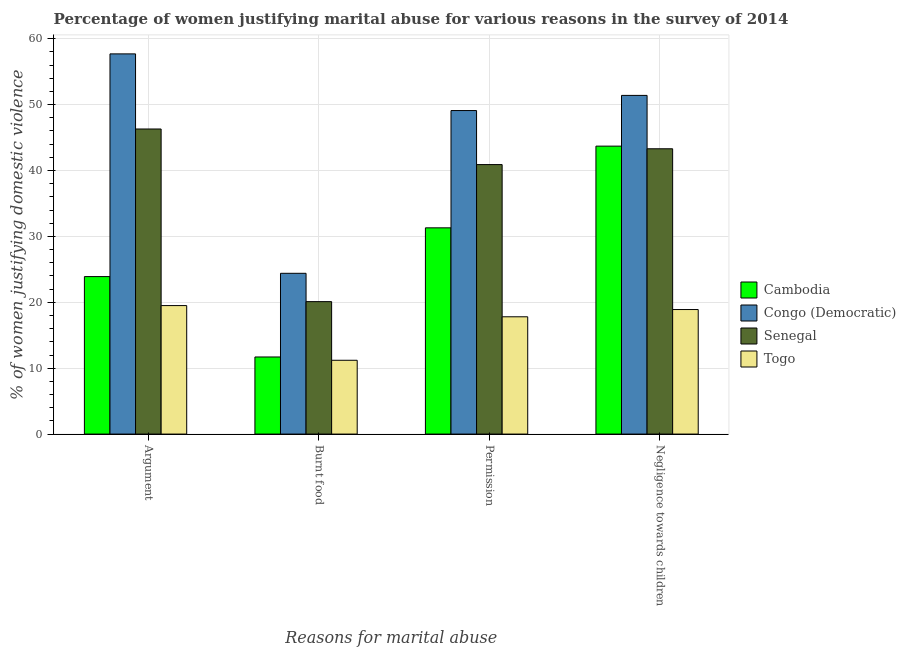How many different coloured bars are there?
Provide a succinct answer. 4. How many groups of bars are there?
Give a very brief answer. 4. Are the number of bars per tick equal to the number of legend labels?
Provide a short and direct response. Yes. What is the label of the 2nd group of bars from the left?
Your response must be concise. Burnt food. What is the percentage of women justifying abuse for showing negligence towards children in Senegal?
Offer a terse response. 43.3. Across all countries, what is the maximum percentage of women justifying abuse in the case of an argument?
Offer a terse response. 57.7. Across all countries, what is the minimum percentage of women justifying abuse for burning food?
Give a very brief answer. 11.2. In which country was the percentage of women justifying abuse for going without permission maximum?
Provide a short and direct response. Congo (Democratic). In which country was the percentage of women justifying abuse for showing negligence towards children minimum?
Give a very brief answer. Togo. What is the total percentage of women justifying abuse for showing negligence towards children in the graph?
Offer a terse response. 157.3. What is the difference between the percentage of women justifying abuse for showing negligence towards children in Congo (Democratic) and that in Cambodia?
Offer a terse response. 7.7. What is the difference between the percentage of women justifying abuse in the case of an argument in Senegal and the percentage of women justifying abuse for showing negligence towards children in Congo (Democratic)?
Ensure brevity in your answer.  -5.1. What is the average percentage of women justifying abuse for going without permission per country?
Offer a terse response. 34.78. What is the difference between the percentage of women justifying abuse for showing negligence towards children and percentage of women justifying abuse for going without permission in Cambodia?
Give a very brief answer. 12.4. In how many countries, is the percentage of women justifying abuse for going without permission greater than 58 %?
Your answer should be compact. 0. What is the ratio of the percentage of women justifying abuse in the case of an argument in Congo (Democratic) to that in Senegal?
Your response must be concise. 1.25. Is the difference between the percentage of women justifying abuse for going without permission in Cambodia and Togo greater than the difference between the percentage of women justifying abuse for burning food in Cambodia and Togo?
Provide a succinct answer. Yes. What is the difference between the highest and the second highest percentage of women justifying abuse for showing negligence towards children?
Provide a short and direct response. 7.7. What is the difference between the highest and the lowest percentage of women justifying abuse for going without permission?
Your response must be concise. 31.3. Is the sum of the percentage of women justifying abuse for showing negligence towards children in Cambodia and Senegal greater than the maximum percentage of women justifying abuse in the case of an argument across all countries?
Make the answer very short. Yes. What does the 4th bar from the left in Permission represents?
Your answer should be very brief. Togo. What does the 2nd bar from the right in Permission represents?
Provide a succinct answer. Senegal. Is it the case that in every country, the sum of the percentage of women justifying abuse in the case of an argument and percentage of women justifying abuse for burning food is greater than the percentage of women justifying abuse for going without permission?
Your answer should be compact. Yes. How many bars are there?
Provide a succinct answer. 16. Are all the bars in the graph horizontal?
Your answer should be compact. No. How many countries are there in the graph?
Your response must be concise. 4. Are the values on the major ticks of Y-axis written in scientific E-notation?
Provide a short and direct response. No. How many legend labels are there?
Give a very brief answer. 4. How are the legend labels stacked?
Give a very brief answer. Vertical. What is the title of the graph?
Provide a short and direct response. Percentage of women justifying marital abuse for various reasons in the survey of 2014. Does "Timor-Leste" appear as one of the legend labels in the graph?
Provide a short and direct response. No. What is the label or title of the X-axis?
Your answer should be compact. Reasons for marital abuse. What is the label or title of the Y-axis?
Give a very brief answer. % of women justifying domestic violence. What is the % of women justifying domestic violence in Cambodia in Argument?
Make the answer very short. 23.9. What is the % of women justifying domestic violence of Congo (Democratic) in Argument?
Make the answer very short. 57.7. What is the % of women justifying domestic violence in Senegal in Argument?
Ensure brevity in your answer.  46.3. What is the % of women justifying domestic violence in Togo in Argument?
Give a very brief answer. 19.5. What is the % of women justifying domestic violence in Cambodia in Burnt food?
Provide a succinct answer. 11.7. What is the % of women justifying domestic violence of Congo (Democratic) in Burnt food?
Offer a very short reply. 24.4. What is the % of women justifying domestic violence in Senegal in Burnt food?
Provide a succinct answer. 20.1. What is the % of women justifying domestic violence in Togo in Burnt food?
Offer a terse response. 11.2. What is the % of women justifying domestic violence in Cambodia in Permission?
Ensure brevity in your answer.  31.3. What is the % of women justifying domestic violence of Congo (Democratic) in Permission?
Make the answer very short. 49.1. What is the % of women justifying domestic violence in Senegal in Permission?
Give a very brief answer. 40.9. What is the % of women justifying domestic violence of Togo in Permission?
Provide a succinct answer. 17.8. What is the % of women justifying domestic violence of Cambodia in Negligence towards children?
Your response must be concise. 43.7. What is the % of women justifying domestic violence in Congo (Democratic) in Negligence towards children?
Ensure brevity in your answer.  51.4. What is the % of women justifying domestic violence of Senegal in Negligence towards children?
Keep it short and to the point. 43.3. What is the % of women justifying domestic violence in Togo in Negligence towards children?
Your answer should be very brief. 18.9. Across all Reasons for marital abuse, what is the maximum % of women justifying domestic violence of Cambodia?
Ensure brevity in your answer.  43.7. Across all Reasons for marital abuse, what is the maximum % of women justifying domestic violence in Congo (Democratic)?
Offer a terse response. 57.7. Across all Reasons for marital abuse, what is the maximum % of women justifying domestic violence in Senegal?
Offer a terse response. 46.3. Across all Reasons for marital abuse, what is the maximum % of women justifying domestic violence in Togo?
Keep it short and to the point. 19.5. Across all Reasons for marital abuse, what is the minimum % of women justifying domestic violence of Cambodia?
Give a very brief answer. 11.7. Across all Reasons for marital abuse, what is the minimum % of women justifying domestic violence in Congo (Democratic)?
Your answer should be very brief. 24.4. Across all Reasons for marital abuse, what is the minimum % of women justifying domestic violence of Senegal?
Provide a succinct answer. 20.1. Across all Reasons for marital abuse, what is the minimum % of women justifying domestic violence of Togo?
Offer a terse response. 11.2. What is the total % of women justifying domestic violence in Cambodia in the graph?
Make the answer very short. 110.6. What is the total % of women justifying domestic violence in Congo (Democratic) in the graph?
Keep it short and to the point. 182.6. What is the total % of women justifying domestic violence of Senegal in the graph?
Ensure brevity in your answer.  150.6. What is the total % of women justifying domestic violence in Togo in the graph?
Provide a succinct answer. 67.4. What is the difference between the % of women justifying domestic violence of Congo (Democratic) in Argument and that in Burnt food?
Your answer should be compact. 33.3. What is the difference between the % of women justifying domestic violence of Senegal in Argument and that in Burnt food?
Make the answer very short. 26.2. What is the difference between the % of women justifying domestic violence in Togo in Argument and that in Burnt food?
Your response must be concise. 8.3. What is the difference between the % of women justifying domestic violence in Togo in Argument and that in Permission?
Make the answer very short. 1.7. What is the difference between the % of women justifying domestic violence in Cambodia in Argument and that in Negligence towards children?
Your response must be concise. -19.8. What is the difference between the % of women justifying domestic violence of Congo (Democratic) in Argument and that in Negligence towards children?
Give a very brief answer. 6.3. What is the difference between the % of women justifying domestic violence of Cambodia in Burnt food and that in Permission?
Ensure brevity in your answer.  -19.6. What is the difference between the % of women justifying domestic violence of Congo (Democratic) in Burnt food and that in Permission?
Ensure brevity in your answer.  -24.7. What is the difference between the % of women justifying domestic violence in Senegal in Burnt food and that in Permission?
Your response must be concise. -20.8. What is the difference between the % of women justifying domestic violence in Togo in Burnt food and that in Permission?
Make the answer very short. -6.6. What is the difference between the % of women justifying domestic violence of Cambodia in Burnt food and that in Negligence towards children?
Provide a succinct answer. -32. What is the difference between the % of women justifying domestic violence in Congo (Democratic) in Burnt food and that in Negligence towards children?
Offer a very short reply. -27. What is the difference between the % of women justifying domestic violence of Senegal in Burnt food and that in Negligence towards children?
Offer a terse response. -23.2. What is the difference between the % of women justifying domestic violence in Togo in Burnt food and that in Negligence towards children?
Ensure brevity in your answer.  -7.7. What is the difference between the % of women justifying domestic violence in Cambodia in Permission and that in Negligence towards children?
Provide a short and direct response. -12.4. What is the difference between the % of women justifying domestic violence in Congo (Democratic) in Permission and that in Negligence towards children?
Make the answer very short. -2.3. What is the difference between the % of women justifying domestic violence of Senegal in Permission and that in Negligence towards children?
Provide a short and direct response. -2.4. What is the difference between the % of women justifying domestic violence of Togo in Permission and that in Negligence towards children?
Offer a terse response. -1.1. What is the difference between the % of women justifying domestic violence in Congo (Democratic) in Argument and the % of women justifying domestic violence in Senegal in Burnt food?
Your answer should be compact. 37.6. What is the difference between the % of women justifying domestic violence of Congo (Democratic) in Argument and the % of women justifying domestic violence of Togo in Burnt food?
Your answer should be very brief. 46.5. What is the difference between the % of women justifying domestic violence of Senegal in Argument and the % of women justifying domestic violence of Togo in Burnt food?
Keep it short and to the point. 35.1. What is the difference between the % of women justifying domestic violence in Cambodia in Argument and the % of women justifying domestic violence in Congo (Democratic) in Permission?
Give a very brief answer. -25.2. What is the difference between the % of women justifying domestic violence of Cambodia in Argument and the % of women justifying domestic violence of Togo in Permission?
Keep it short and to the point. 6.1. What is the difference between the % of women justifying domestic violence in Congo (Democratic) in Argument and the % of women justifying domestic violence in Togo in Permission?
Offer a terse response. 39.9. What is the difference between the % of women justifying domestic violence in Cambodia in Argument and the % of women justifying domestic violence in Congo (Democratic) in Negligence towards children?
Provide a succinct answer. -27.5. What is the difference between the % of women justifying domestic violence of Cambodia in Argument and the % of women justifying domestic violence of Senegal in Negligence towards children?
Ensure brevity in your answer.  -19.4. What is the difference between the % of women justifying domestic violence in Cambodia in Argument and the % of women justifying domestic violence in Togo in Negligence towards children?
Offer a terse response. 5. What is the difference between the % of women justifying domestic violence of Congo (Democratic) in Argument and the % of women justifying domestic violence of Togo in Negligence towards children?
Your answer should be very brief. 38.8. What is the difference between the % of women justifying domestic violence of Senegal in Argument and the % of women justifying domestic violence of Togo in Negligence towards children?
Provide a short and direct response. 27.4. What is the difference between the % of women justifying domestic violence of Cambodia in Burnt food and the % of women justifying domestic violence of Congo (Democratic) in Permission?
Provide a succinct answer. -37.4. What is the difference between the % of women justifying domestic violence in Cambodia in Burnt food and the % of women justifying domestic violence in Senegal in Permission?
Your answer should be compact. -29.2. What is the difference between the % of women justifying domestic violence in Congo (Democratic) in Burnt food and the % of women justifying domestic violence in Senegal in Permission?
Your answer should be compact. -16.5. What is the difference between the % of women justifying domestic violence of Congo (Democratic) in Burnt food and the % of women justifying domestic violence of Togo in Permission?
Make the answer very short. 6.6. What is the difference between the % of women justifying domestic violence in Cambodia in Burnt food and the % of women justifying domestic violence in Congo (Democratic) in Negligence towards children?
Your answer should be compact. -39.7. What is the difference between the % of women justifying domestic violence of Cambodia in Burnt food and the % of women justifying domestic violence of Senegal in Negligence towards children?
Your answer should be very brief. -31.6. What is the difference between the % of women justifying domestic violence in Cambodia in Burnt food and the % of women justifying domestic violence in Togo in Negligence towards children?
Your response must be concise. -7.2. What is the difference between the % of women justifying domestic violence in Congo (Democratic) in Burnt food and the % of women justifying domestic violence in Senegal in Negligence towards children?
Your response must be concise. -18.9. What is the difference between the % of women justifying domestic violence of Congo (Democratic) in Burnt food and the % of women justifying domestic violence of Togo in Negligence towards children?
Your response must be concise. 5.5. What is the difference between the % of women justifying domestic violence of Cambodia in Permission and the % of women justifying domestic violence of Congo (Democratic) in Negligence towards children?
Your answer should be very brief. -20.1. What is the difference between the % of women justifying domestic violence in Cambodia in Permission and the % of women justifying domestic violence in Senegal in Negligence towards children?
Offer a terse response. -12. What is the difference between the % of women justifying domestic violence of Cambodia in Permission and the % of women justifying domestic violence of Togo in Negligence towards children?
Give a very brief answer. 12.4. What is the difference between the % of women justifying domestic violence of Congo (Democratic) in Permission and the % of women justifying domestic violence of Togo in Negligence towards children?
Your answer should be compact. 30.2. What is the difference between the % of women justifying domestic violence of Senegal in Permission and the % of women justifying domestic violence of Togo in Negligence towards children?
Your response must be concise. 22. What is the average % of women justifying domestic violence in Cambodia per Reasons for marital abuse?
Offer a terse response. 27.65. What is the average % of women justifying domestic violence in Congo (Democratic) per Reasons for marital abuse?
Ensure brevity in your answer.  45.65. What is the average % of women justifying domestic violence of Senegal per Reasons for marital abuse?
Provide a short and direct response. 37.65. What is the average % of women justifying domestic violence in Togo per Reasons for marital abuse?
Give a very brief answer. 16.85. What is the difference between the % of women justifying domestic violence of Cambodia and % of women justifying domestic violence of Congo (Democratic) in Argument?
Provide a short and direct response. -33.8. What is the difference between the % of women justifying domestic violence of Cambodia and % of women justifying domestic violence of Senegal in Argument?
Give a very brief answer. -22.4. What is the difference between the % of women justifying domestic violence of Cambodia and % of women justifying domestic violence of Togo in Argument?
Ensure brevity in your answer.  4.4. What is the difference between the % of women justifying domestic violence of Congo (Democratic) and % of women justifying domestic violence of Togo in Argument?
Provide a short and direct response. 38.2. What is the difference between the % of women justifying domestic violence in Senegal and % of women justifying domestic violence in Togo in Argument?
Ensure brevity in your answer.  26.8. What is the difference between the % of women justifying domestic violence in Congo (Democratic) and % of women justifying domestic violence in Senegal in Burnt food?
Keep it short and to the point. 4.3. What is the difference between the % of women justifying domestic violence in Congo (Democratic) and % of women justifying domestic violence in Togo in Burnt food?
Your answer should be compact. 13.2. What is the difference between the % of women justifying domestic violence in Cambodia and % of women justifying domestic violence in Congo (Democratic) in Permission?
Make the answer very short. -17.8. What is the difference between the % of women justifying domestic violence of Cambodia and % of women justifying domestic violence of Togo in Permission?
Provide a short and direct response. 13.5. What is the difference between the % of women justifying domestic violence in Congo (Democratic) and % of women justifying domestic violence in Togo in Permission?
Ensure brevity in your answer.  31.3. What is the difference between the % of women justifying domestic violence in Senegal and % of women justifying domestic violence in Togo in Permission?
Ensure brevity in your answer.  23.1. What is the difference between the % of women justifying domestic violence of Cambodia and % of women justifying domestic violence of Togo in Negligence towards children?
Offer a very short reply. 24.8. What is the difference between the % of women justifying domestic violence of Congo (Democratic) and % of women justifying domestic violence of Senegal in Negligence towards children?
Offer a terse response. 8.1. What is the difference between the % of women justifying domestic violence in Congo (Democratic) and % of women justifying domestic violence in Togo in Negligence towards children?
Provide a short and direct response. 32.5. What is the difference between the % of women justifying domestic violence in Senegal and % of women justifying domestic violence in Togo in Negligence towards children?
Your answer should be compact. 24.4. What is the ratio of the % of women justifying domestic violence in Cambodia in Argument to that in Burnt food?
Offer a terse response. 2.04. What is the ratio of the % of women justifying domestic violence of Congo (Democratic) in Argument to that in Burnt food?
Keep it short and to the point. 2.36. What is the ratio of the % of women justifying domestic violence in Senegal in Argument to that in Burnt food?
Give a very brief answer. 2.3. What is the ratio of the % of women justifying domestic violence of Togo in Argument to that in Burnt food?
Your answer should be compact. 1.74. What is the ratio of the % of women justifying domestic violence in Cambodia in Argument to that in Permission?
Offer a terse response. 0.76. What is the ratio of the % of women justifying domestic violence of Congo (Democratic) in Argument to that in Permission?
Keep it short and to the point. 1.18. What is the ratio of the % of women justifying domestic violence of Senegal in Argument to that in Permission?
Ensure brevity in your answer.  1.13. What is the ratio of the % of women justifying domestic violence of Togo in Argument to that in Permission?
Make the answer very short. 1.1. What is the ratio of the % of women justifying domestic violence in Cambodia in Argument to that in Negligence towards children?
Give a very brief answer. 0.55. What is the ratio of the % of women justifying domestic violence of Congo (Democratic) in Argument to that in Negligence towards children?
Offer a very short reply. 1.12. What is the ratio of the % of women justifying domestic violence in Senegal in Argument to that in Negligence towards children?
Your response must be concise. 1.07. What is the ratio of the % of women justifying domestic violence in Togo in Argument to that in Negligence towards children?
Offer a very short reply. 1.03. What is the ratio of the % of women justifying domestic violence in Cambodia in Burnt food to that in Permission?
Offer a very short reply. 0.37. What is the ratio of the % of women justifying domestic violence in Congo (Democratic) in Burnt food to that in Permission?
Provide a short and direct response. 0.5. What is the ratio of the % of women justifying domestic violence in Senegal in Burnt food to that in Permission?
Offer a terse response. 0.49. What is the ratio of the % of women justifying domestic violence in Togo in Burnt food to that in Permission?
Your response must be concise. 0.63. What is the ratio of the % of women justifying domestic violence of Cambodia in Burnt food to that in Negligence towards children?
Provide a short and direct response. 0.27. What is the ratio of the % of women justifying domestic violence in Congo (Democratic) in Burnt food to that in Negligence towards children?
Your response must be concise. 0.47. What is the ratio of the % of women justifying domestic violence of Senegal in Burnt food to that in Negligence towards children?
Your response must be concise. 0.46. What is the ratio of the % of women justifying domestic violence of Togo in Burnt food to that in Negligence towards children?
Your answer should be compact. 0.59. What is the ratio of the % of women justifying domestic violence of Cambodia in Permission to that in Negligence towards children?
Your response must be concise. 0.72. What is the ratio of the % of women justifying domestic violence of Congo (Democratic) in Permission to that in Negligence towards children?
Provide a short and direct response. 0.96. What is the ratio of the % of women justifying domestic violence of Senegal in Permission to that in Negligence towards children?
Provide a succinct answer. 0.94. What is the ratio of the % of women justifying domestic violence of Togo in Permission to that in Negligence towards children?
Ensure brevity in your answer.  0.94. What is the difference between the highest and the lowest % of women justifying domestic violence of Congo (Democratic)?
Give a very brief answer. 33.3. What is the difference between the highest and the lowest % of women justifying domestic violence of Senegal?
Make the answer very short. 26.2. What is the difference between the highest and the lowest % of women justifying domestic violence of Togo?
Ensure brevity in your answer.  8.3. 